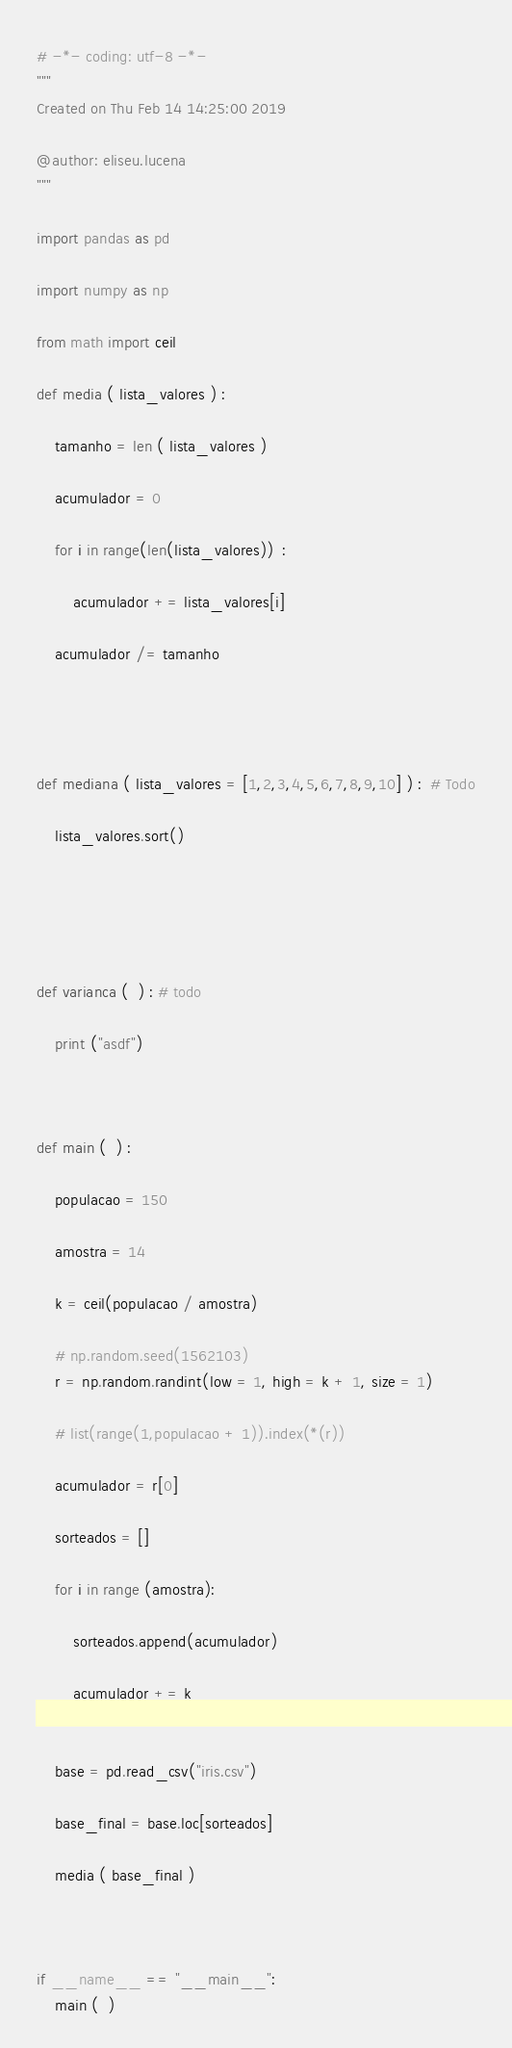<code> <loc_0><loc_0><loc_500><loc_500><_Python_># -*- coding: utf-8 -*-
"""
Created on Thu Feb 14 14:25:00 2019

@author: eliseu.lucena
"""

import pandas as pd

import numpy as np

from math import ceil

def media ( lista_valores ) :
    
    tamanho = len ( lista_valores )
    
    acumulador = 0
    
    for i in range(len(lista_valores))  :
        
        acumulador += lista_valores[i]
        
    acumulador /= tamanho
        
    
    
    
def mediana ( lista_valores = [1,2,3,4,5,6,7,8,9,10] ) :  # Todo
    
    lista_valores.sort()
    
    
    
    
    
def varianca (  ) : # todo
        
    print ("asdf")
    
    

def main (  ) :
    
    populacao = 150
    
    amostra = 14
    
    k = ceil(populacao / amostra)
    
    # np.random.seed(1562103)
    r = np.random.randint(low = 1, high = k + 1, size = 1)
    
    # list(range(1,populacao + 1)).index(*(r))
    
    acumulador = r[0]
    
    sorteados = []
    
    for i in range (amostra):
        
        sorteados.append(acumulador)
        
        acumulador += k
    
    
    base = pd.read_csv("iris.csv")
    
    base_final = base.loc[sorteados]
    
    media ( base_final )
    
    
    
if __name__ == "__main__":
    main (  )
</code> 